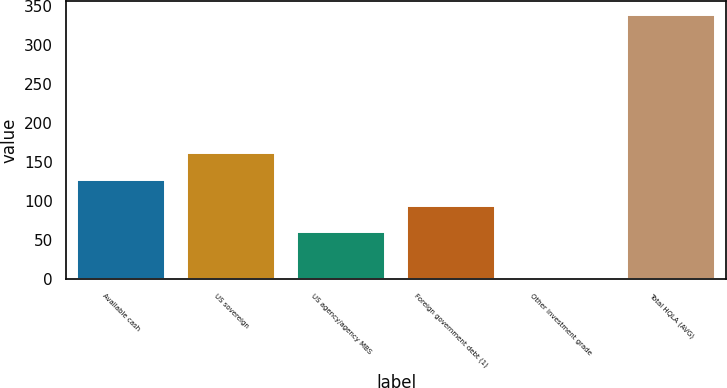Convert chart to OTSL. <chart><loc_0><loc_0><loc_500><loc_500><bar_chart><fcel>Available cash<fcel>US sovereign<fcel>US agency/agency MBS<fcel>Foreign government debt (1)<fcel>Other investment grade<fcel>Total HQLA (AVG)<nl><fcel>127.42<fcel>161.13<fcel>60<fcel>93.71<fcel>1.5<fcel>338.6<nl></chart> 